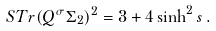Convert formula to latex. <formula><loc_0><loc_0><loc_500><loc_500>S T r ( Q ^ { \sigma } \Sigma _ { 2 } ) ^ { 2 } = 3 + 4 \sinh ^ { 2 } s \, .</formula> 